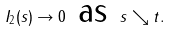Convert formula to latex. <formula><loc_0><loc_0><loc_500><loc_500>I _ { 2 } ( s ) \rightarrow 0 \text { as } s \searrow t .</formula> 